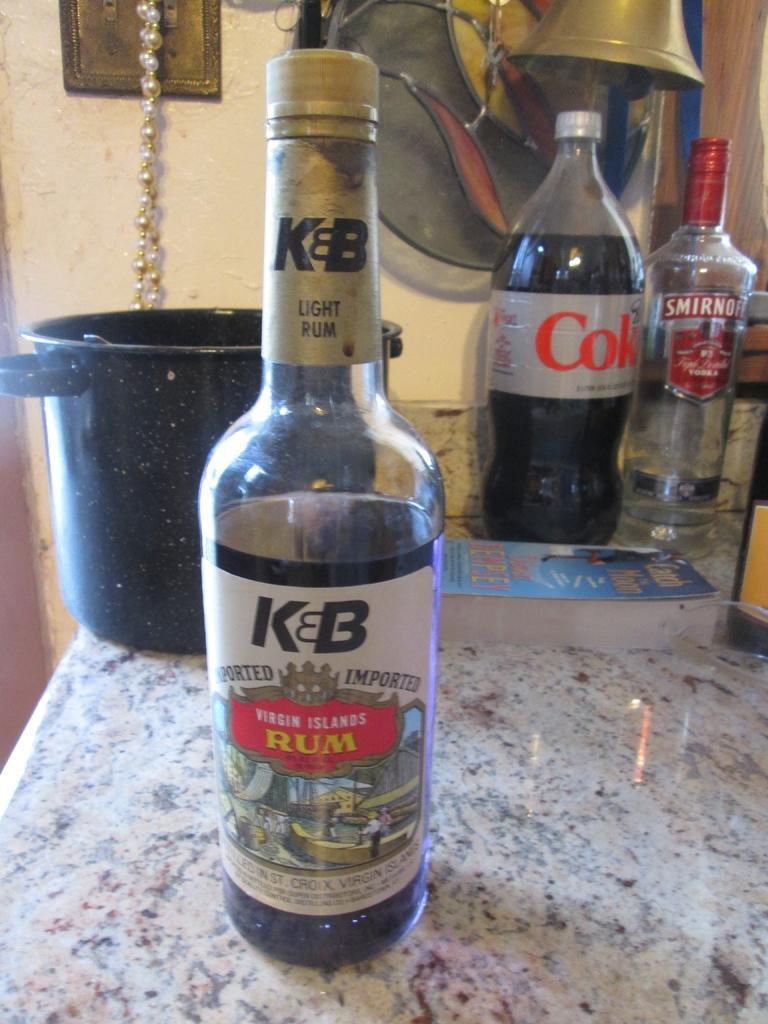Provide a one-sentence caption for the provided image. bottle of open rum and coke on the counter. 